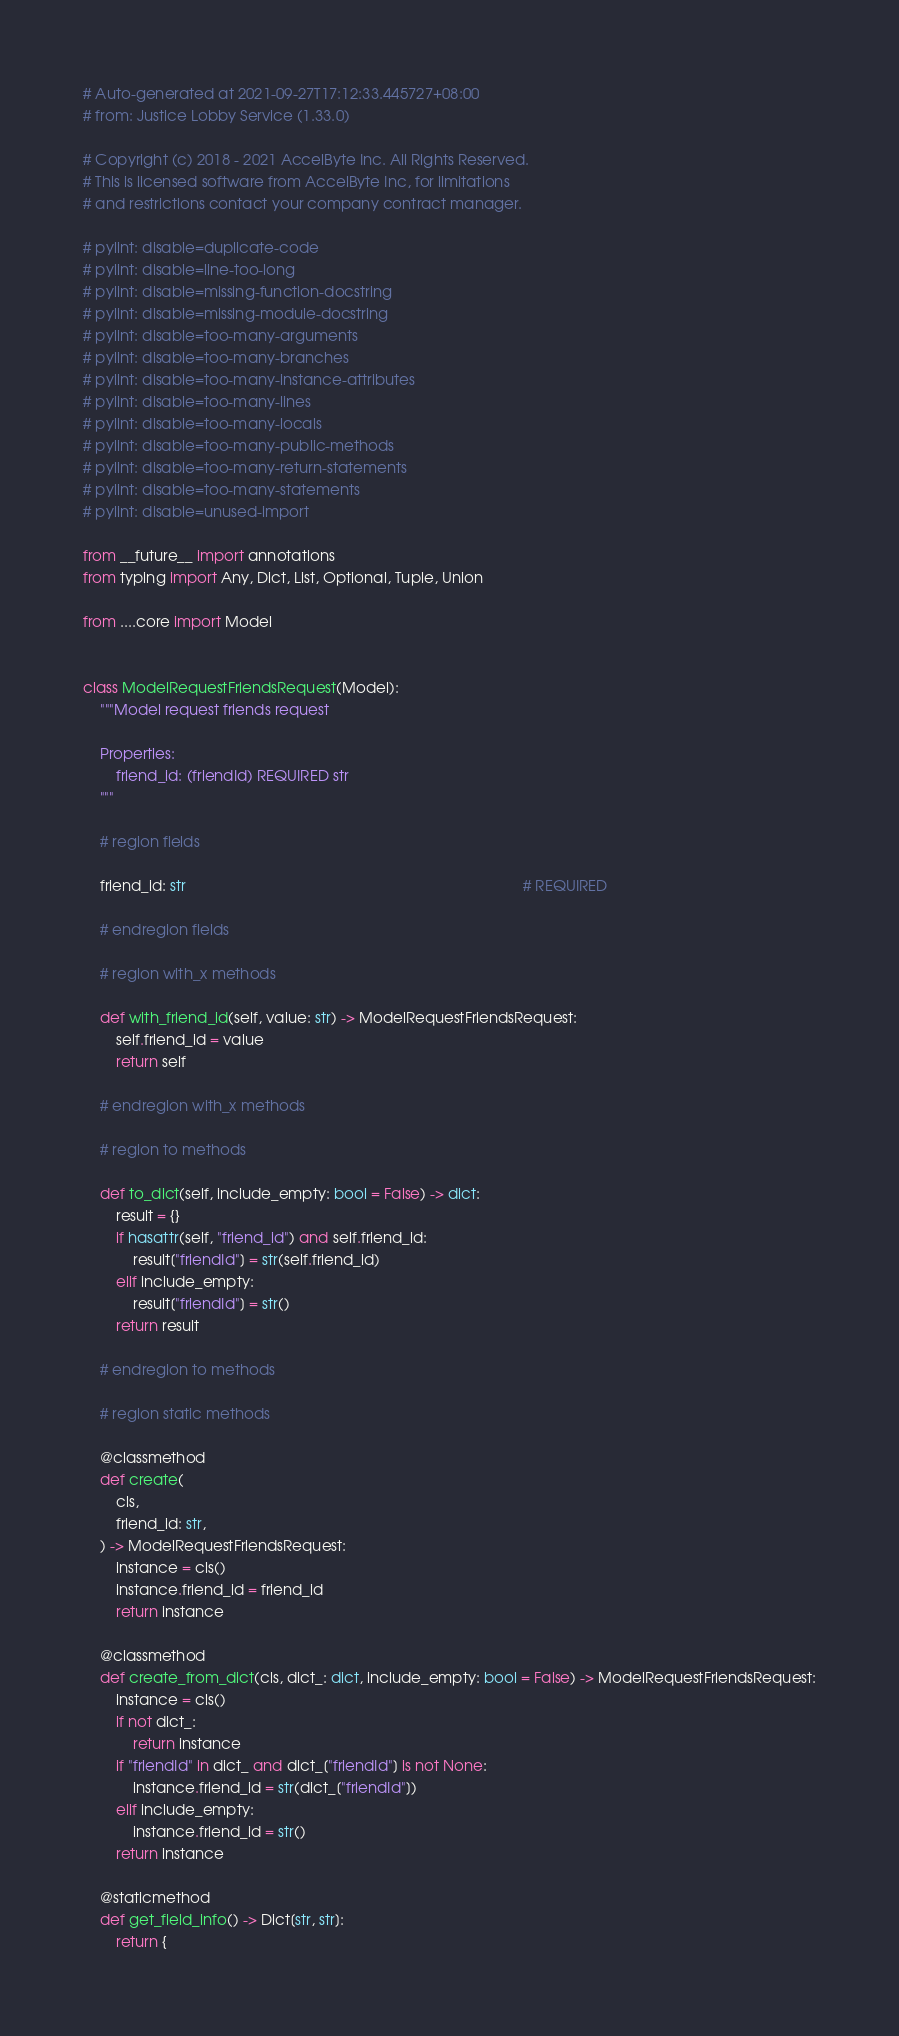<code> <loc_0><loc_0><loc_500><loc_500><_Python_># Auto-generated at 2021-09-27T17:12:33.445727+08:00
# from: Justice Lobby Service (1.33.0)

# Copyright (c) 2018 - 2021 AccelByte Inc. All Rights Reserved.
# This is licensed software from AccelByte Inc, for limitations
# and restrictions contact your company contract manager.

# pylint: disable=duplicate-code
# pylint: disable=line-too-long
# pylint: disable=missing-function-docstring
# pylint: disable=missing-module-docstring
# pylint: disable=too-many-arguments
# pylint: disable=too-many-branches
# pylint: disable=too-many-instance-attributes
# pylint: disable=too-many-lines
# pylint: disable=too-many-locals
# pylint: disable=too-many-public-methods
# pylint: disable=too-many-return-statements
# pylint: disable=too-many-statements
# pylint: disable=unused-import

from __future__ import annotations
from typing import Any, Dict, List, Optional, Tuple, Union

from ....core import Model


class ModelRequestFriendsRequest(Model):
    """Model request friends request

    Properties:
        friend_id: (friendId) REQUIRED str
    """

    # region fields

    friend_id: str                                                                                 # REQUIRED

    # endregion fields

    # region with_x methods

    def with_friend_id(self, value: str) -> ModelRequestFriendsRequest:
        self.friend_id = value
        return self

    # endregion with_x methods

    # region to methods

    def to_dict(self, include_empty: bool = False) -> dict:
        result = {}
        if hasattr(self, "friend_id") and self.friend_id:
            result["friendId"] = str(self.friend_id)
        elif include_empty:
            result["friendId"] = str()
        return result

    # endregion to methods

    # region static methods

    @classmethod
    def create(
        cls,
        friend_id: str,
    ) -> ModelRequestFriendsRequest:
        instance = cls()
        instance.friend_id = friend_id
        return instance

    @classmethod
    def create_from_dict(cls, dict_: dict, include_empty: bool = False) -> ModelRequestFriendsRequest:
        instance = cls()
        if not dict_:
            return instance
        if "friendId" in dict_ and dict_["friendId"] is not None:
            instance.friend_id = str(dict_["friendId"])
        elif include_empty:
            instance.friend_id = str()
        return instance

    @staticmethod
    def get_field_info() -> Dict[str, str]:
        return {</code> 